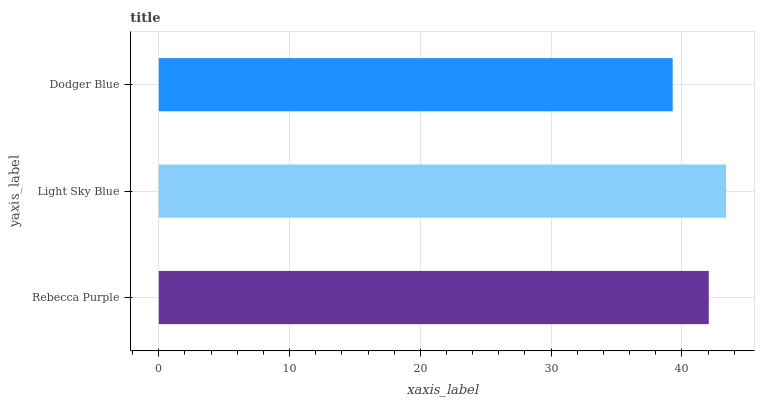Is Dodger Blue the minimum?
Answer yes or no. Yes. Is Light Sky Blue the maximum?
Answer yes or no. Yes. Is Light Sky Blue the minimum?
Answer yes or no. No. Is Dodger Blue the maximum?
Answer yes or no. No. Is Light Sky Blue greater than Dodger Blue?
Answer yes or no. Yes. Is Dodger Blue less than Light Sky Blue?
Answer yes or no. Yes. Is Dodger Blue greater than Light Sky Blue?
Answer yes or no. No. Is Light Sky Blue less than Dodger Blue?
Answer yes or no. No. Is Rebecca Purple the high median?
Answer yes or no. Yes. Is Rebecca Purple the low median?
Answer yes or no. Yes. Is Light Sky Blue the high median?
Answer yes or no. No. Is Light Sky Blue the low median?
Answer yes or no. No. 